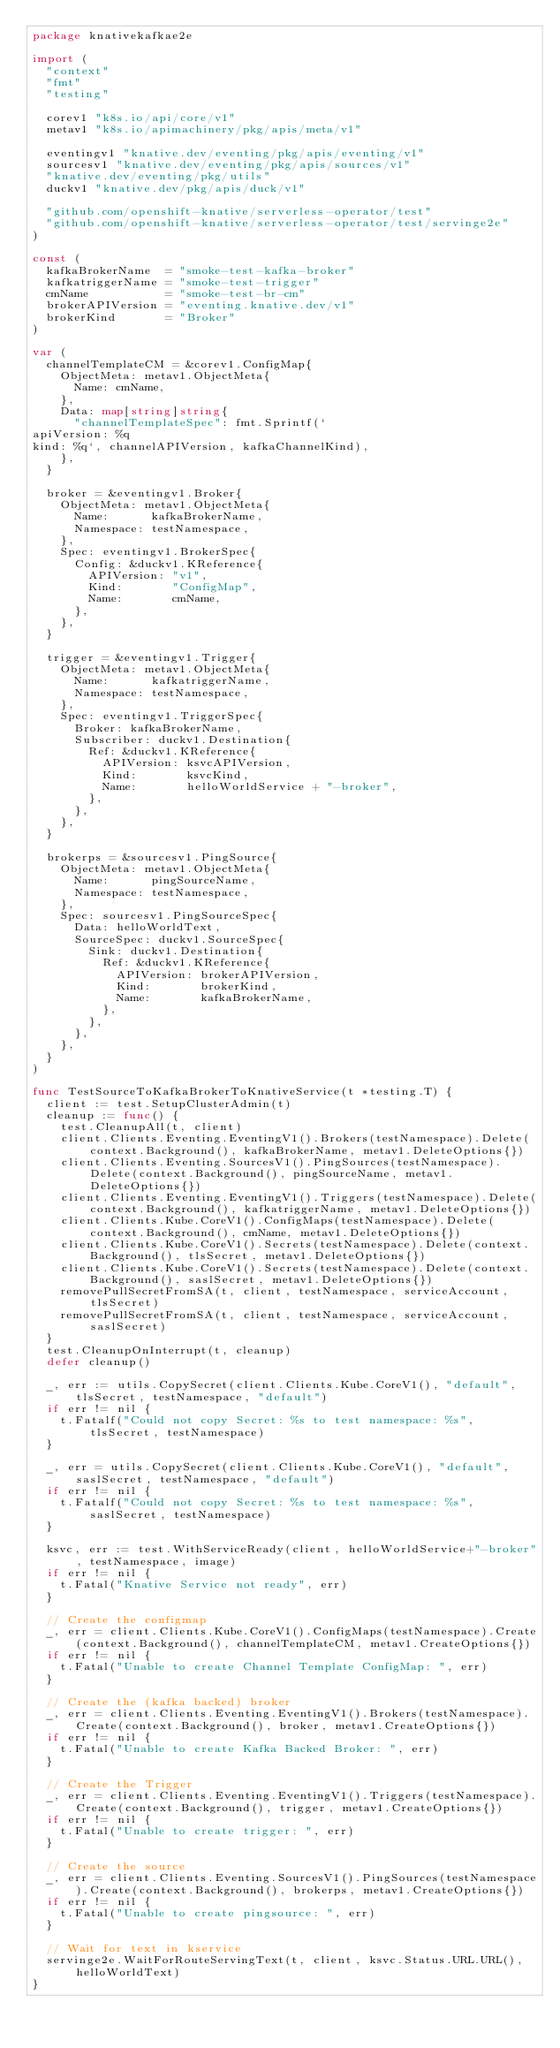Convert code to text. <code><loc_0><loc_0><loc_500><loc_500><_Go_>package knativekafkae2e

import (
	"context"
	"fmt"
	"testing"

	corev1 "k8s.io/api/core/v1"
	metav1 "k8s.io/apimachinery/pkg/apis/meta/v1"

	eventingv1 "knative.dev/eventing/pkg/apis/eventing/v1"
	sourcesv1 "knative.dev/eventing/pkg/apis/sources/v1"
	"knative.dev/eventing/pkg/utils"
	duckv1 "knative.dev/pkg/apis/duck/v1"

	"github.com/openshift-knative/serverless-operator/test"
	"github.com/openshift-knative/serverless-operator/test/servinge2e"
)

const (
	kafkaBrokerName  = "smoke-test-kafka-broker"
	kafkatriggerName = "smoke-test-trigger"
	cmName           = "smoke-test-br-cm"
	brokerAPIVersion = "eventing.knative.dev/v1"
	brokerKind       = "Broker"
)

var (
	channelTemplateCM = &corev1.ConfigMap{
		ObjectMeta: metav1.ObjectMeta{
			Name: cmName,
		},
		Data: map[string]string{
			"channelTemplateSpec": fmt.Sprintf(`
apiVersion: %q
kind: %q`, channelAPIVersion, kafkaChannelKind),
		},
	}

	broker = &eventingv1.Broker{
		ObjectMeta: metav1.ObjectMeta{
			Name:      kafkaBrokerName,
			Namespace: testNamespace,
		},
		Spec: eventingv1.BrokerSpec{
			Config: &duckv1.KReference{
				APIVersion: "v1",
				Kind:       "ConfigMap",
				Name:       cmName,
			},
		},
	}

	trigger = &eventingv1.Trigger{
		ObjectMeta: metav1.ObjectMeta{
			Name:      kafkatriggerName,
			Namespace: testNamespace,
		},
		Spec: eventingv1.TriggerSpec{
			Broker: kafkaBrokerName,
			Subscriber: duckv1.Destination{
				Ref: &duckv1.KReference{
					APIVersion: ksvcAPIVersion,
					Kind:       ksvcKind,
					Name:       helloWorldService + "-broker",
				},
			},
		},
	}

	brokerps = &sourcesv1.PingSource{
		ObjectMeta: metav1.ObjectMeta{
			Name:      pingSourceName,
			Namespace: testNamespace,
		},
		Spec: sourcesv1.PingSourceSpec{
			Data: helloWorldText,
			SourceSpec: duckv1.SourceSpec{
				Sink: duckv1.Destination{
					Ref: &duckv1.KReference{
						APIVersion: brokerAPIVersion,
						Kind:       brokerKind,
						Name:       kafkaBrokerName,
					},
				},
			},
		},
	}
)

func TestSourceToKafkaBrokerToKnativeService(t *testing.T) {
	client := test.SetupClusterAdmin(t)
	cleanup := func() {
		test.CleanupAll(t, client)
		client.Clients.Eventing.EventingV1().Brokers(testNamespace).Delete(context.Background(), kafkaBrokerName, metav1.DeleteOptions{})
		client.Clients.Eventing.SourcesV1().PingSources(testNamespace).Delete(context.Background(), pingSourceName, metav1.DeleteOptions{})
		client.Clients.Eventing.EventingV1().Triggers(testNamespace).Delete(context.Background(), kafkatriggerName, metav1.DeleteOptions{})
		client.Clients.Kube.CoreV1().ConfigMaps(testNamespace).Delete(context.Background(), cmName, metav1.DeleteOptions{})
		client.Clients.Kube.CoreV1().Secrets(testNamespace).Delete(context.Background(), tlsSecret, metav1.DeleteOptions{})
		client.Clients.Kube.CoreV1().Secrets(testNamespace).Delete(context.Background(), saslSecret, metav1.DeleteOptions{})
		removePullSecretFromSA(t, client, testNamespace, serviceAccount, tlsSecret)
		removePullSecretFromSA(t, client, testNamespace, serviceAccount, saslSecret)
	}
	test.CleanupOnInterrupt(t, cleanup)
	defer cleanup()

	_, err := utils.CopySecret(client.Clients.Kube.CoreV1(), "default", tlsSecret, testNamespace, "default")
	if err != nil {
		t.Fatalf("Could not copy Secret: %s to test namespace: %s", tlsSecret, testNamespace)
	}

	_, err = utils.CopySecret(client.Clients.Kube.CoreV1(), "default", saslSecret, testNamespace, "default")
	if err != nil {
		t.Fatalf("Could not copy Secret: %s to test namespace: %s", saslSecret, testNamespace)
	}

	ksvc, err := test.WithServiceReady(client, helloWorldService+"-broker", testNamespace, image)
	if err != nil {
		t.Fatal("Knative Service not ready", err)
	}

	// Create the configmap
	_, err = client.Clients.Kube.CoreV1().ConfigMaps(testNamespace).Create(context.Background(), channelTemplateCM, metav1.CreateOptions{})
	if err != nil {
		t.Fatal("Unable to create Channel Template ConfigMap: ", err)
	}

	// Create the (kafka backed) broker
	_, err = client.Clients.Eventing.EventingV1().Brokers(testNamespace).Create(context.Background(), broker, metav1.CreateOptions{})
	if err != nil {
		t.Fatal("Unable to create Kafka Backed Broker: ", err)
	}

	// Create the Trigger
	_, err = client.Clients.Eventing.EventingV1().Triggers(testNamespace).Create(context.Background(), trigger, metav1.CreateOptions{})
	if err != nil {
		t.Fatal("Unable to create trigger: ", err)
	}

	// Create the source
	_, err = client.Clients.Eventing.SourcesV1().PingSources(testNamespace).Create(context.Background(), brokerps, metav1.CreateOptions{})
	if err != nil {
		t.Fatal("Unable to create pingsource: ", err)
	}

	// Wait for text in kservice
	servinge2e.WaitForRouteServingText(t, client, ksvc.Status.URL.URL(), helloWorldText)
}
</code> 